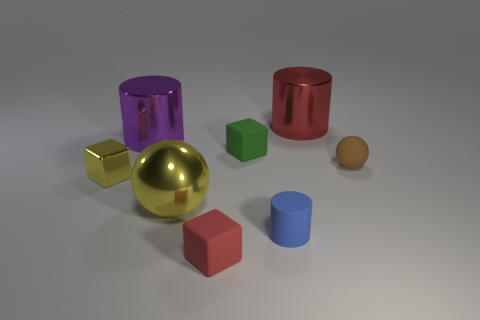Subtract all red cubes. Subtract all purple balls. How many cubes are left? 2 Add 1 tiny yellow cubes. How many objects exist? 9 Subtract all cylinders. How many objects are left? 5 Add 5 tiny cyan cylinders. How many tiny cyan cylinders exist? 5 Subtract 1 yellow blocks. How many objects are left? 7 Subtract all yellow blocks. Subtract all big blue metallic cylinders. How many objects are left? 7 Add 1 small yellow cubes. How many small yellow cubes are left? 2 